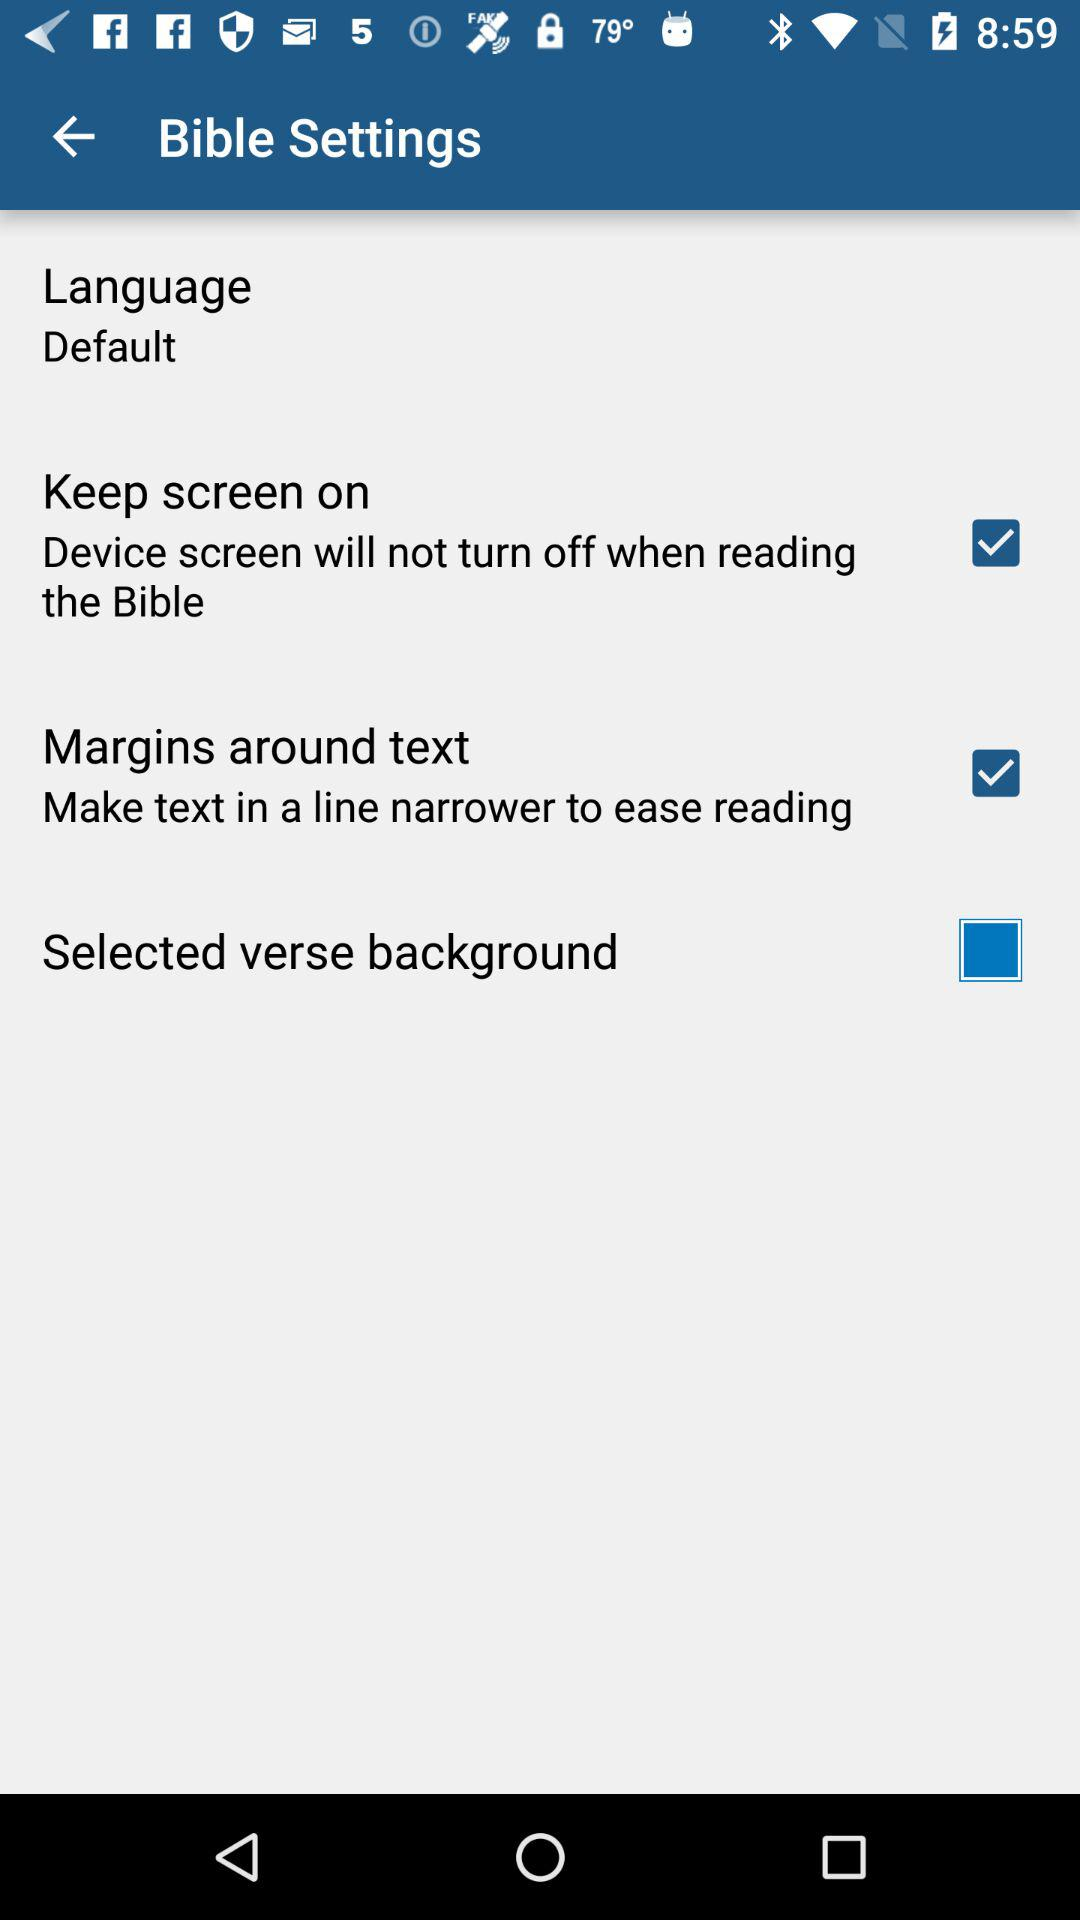What is the status of "Keep screen on"? The status of "Keep screen on" is "on". 